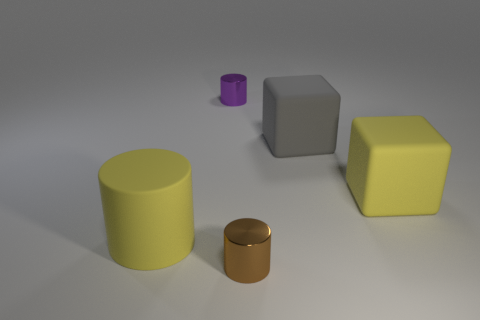Add 4 purple cylinders. How many objects exist? 9 Subtract all cylinders. How many objects are left? 2 Subtract 1 gray cubes. How many objects are left? 4 Subtract all purple metallic things. Subtract all small purple cylinders. How many objects are left? 3 Add 3 brown cylinders. How many brown cylinders are left? 4 Add 2 large purple metallic cubes. How many large purple metallic cubes exist? 2 